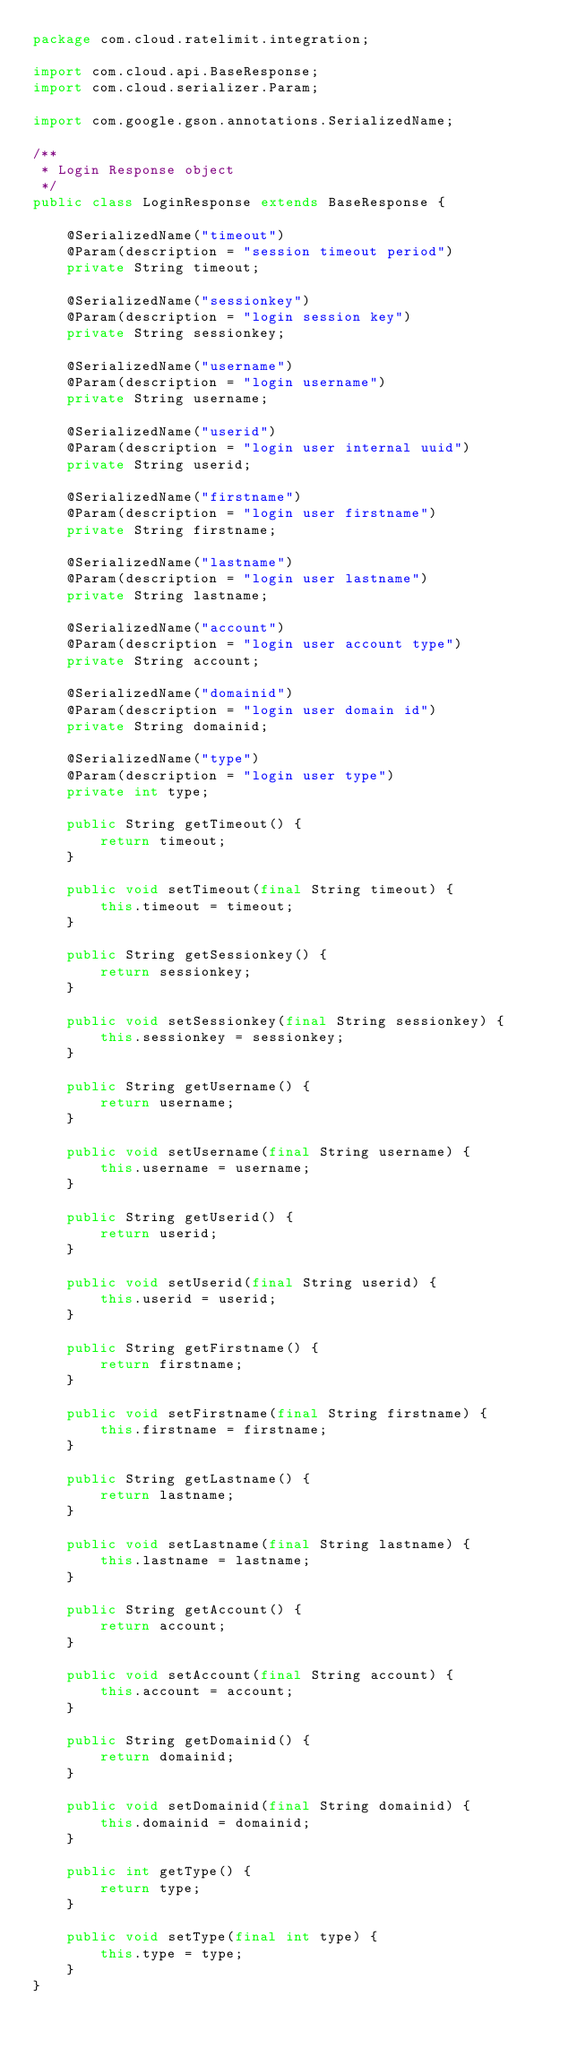Convert code to text. <code><loc_0><loc_0><loc_500><loc_500><_Java_>package com.cloud.ratelimit.integration;

import com.cloud.api.BaseResponse;
import com.cloud.serializer.Param;

import com.google.gson.annotations.SerializedName;

/**
 * Login Response object
 */
public class LoginResponse extends BaseResponse {

    @SerializedName("timeout")
    @Param(description = "session timeout period")
    private String timeout;

    @SerializedName("sessionkey")
    @Param(description = "login session key")
    private String sessionkey;

    @SerializedName("username")
    @Param(description = "login username")
    private String username;

    @SerializedName("userid")
    @Param(description = "login user internal uuid")
    private String userid;

    @SerializedName("firstname")
    @Param(description = "login user firstname")
    private String firstname;

    @SerializedName("lastname")
    @Param(description = "login user lastname")
    private String lastname;

    @SerializedName("account")
    @Param(description = "login user account type")
    private String account;

    @SerializedName("domainid")
    @Param(description = "login user domain id")
    private String domainid;

    @SerializedName("type")
    @Param(description = "login user type")
    private int type;

    public String getTimeout() {
        return timeout;
    }

    public void setTimeout(final String timeout) {
        this.timeout = timeout;
    }

    public String getSessionkey() {
        return sessionkey;
    }

    public void setSessionkey(final String sessionkey) {
        this.sessionkey = sessionkey;
    }

    public String getUsername() {
        return username;
    }

    public void setUsername(final String username) {
        this.username = username;
    }

    public String getUserid() {
        return userid;
    }

    public void setUserid(final String userid) {
        this.userid = userid;
    }

    public String getFirstname() {
        return firstname;
    }

    public void setFirstname(final String firstname) {
        this.firstname = firstname;
    }

    public String getLastname() {
        return lastname;
    }

    public void setLastname(final String lastname) {
        this.lastname = lastname;
    }

    public String getAccount() {
        return account;
    }

    public void setAccount(final String account) {
        this.account = account;
    }

    public String getDomainid() {
        return domainid;
    }

    public void setDomainid(final String domainid) {
        this.domainid = domainid;
    }

    public int getType() {
        return type;
    }

    public void setType(final int type) {
        this.type = type;
    }
}
</code> 